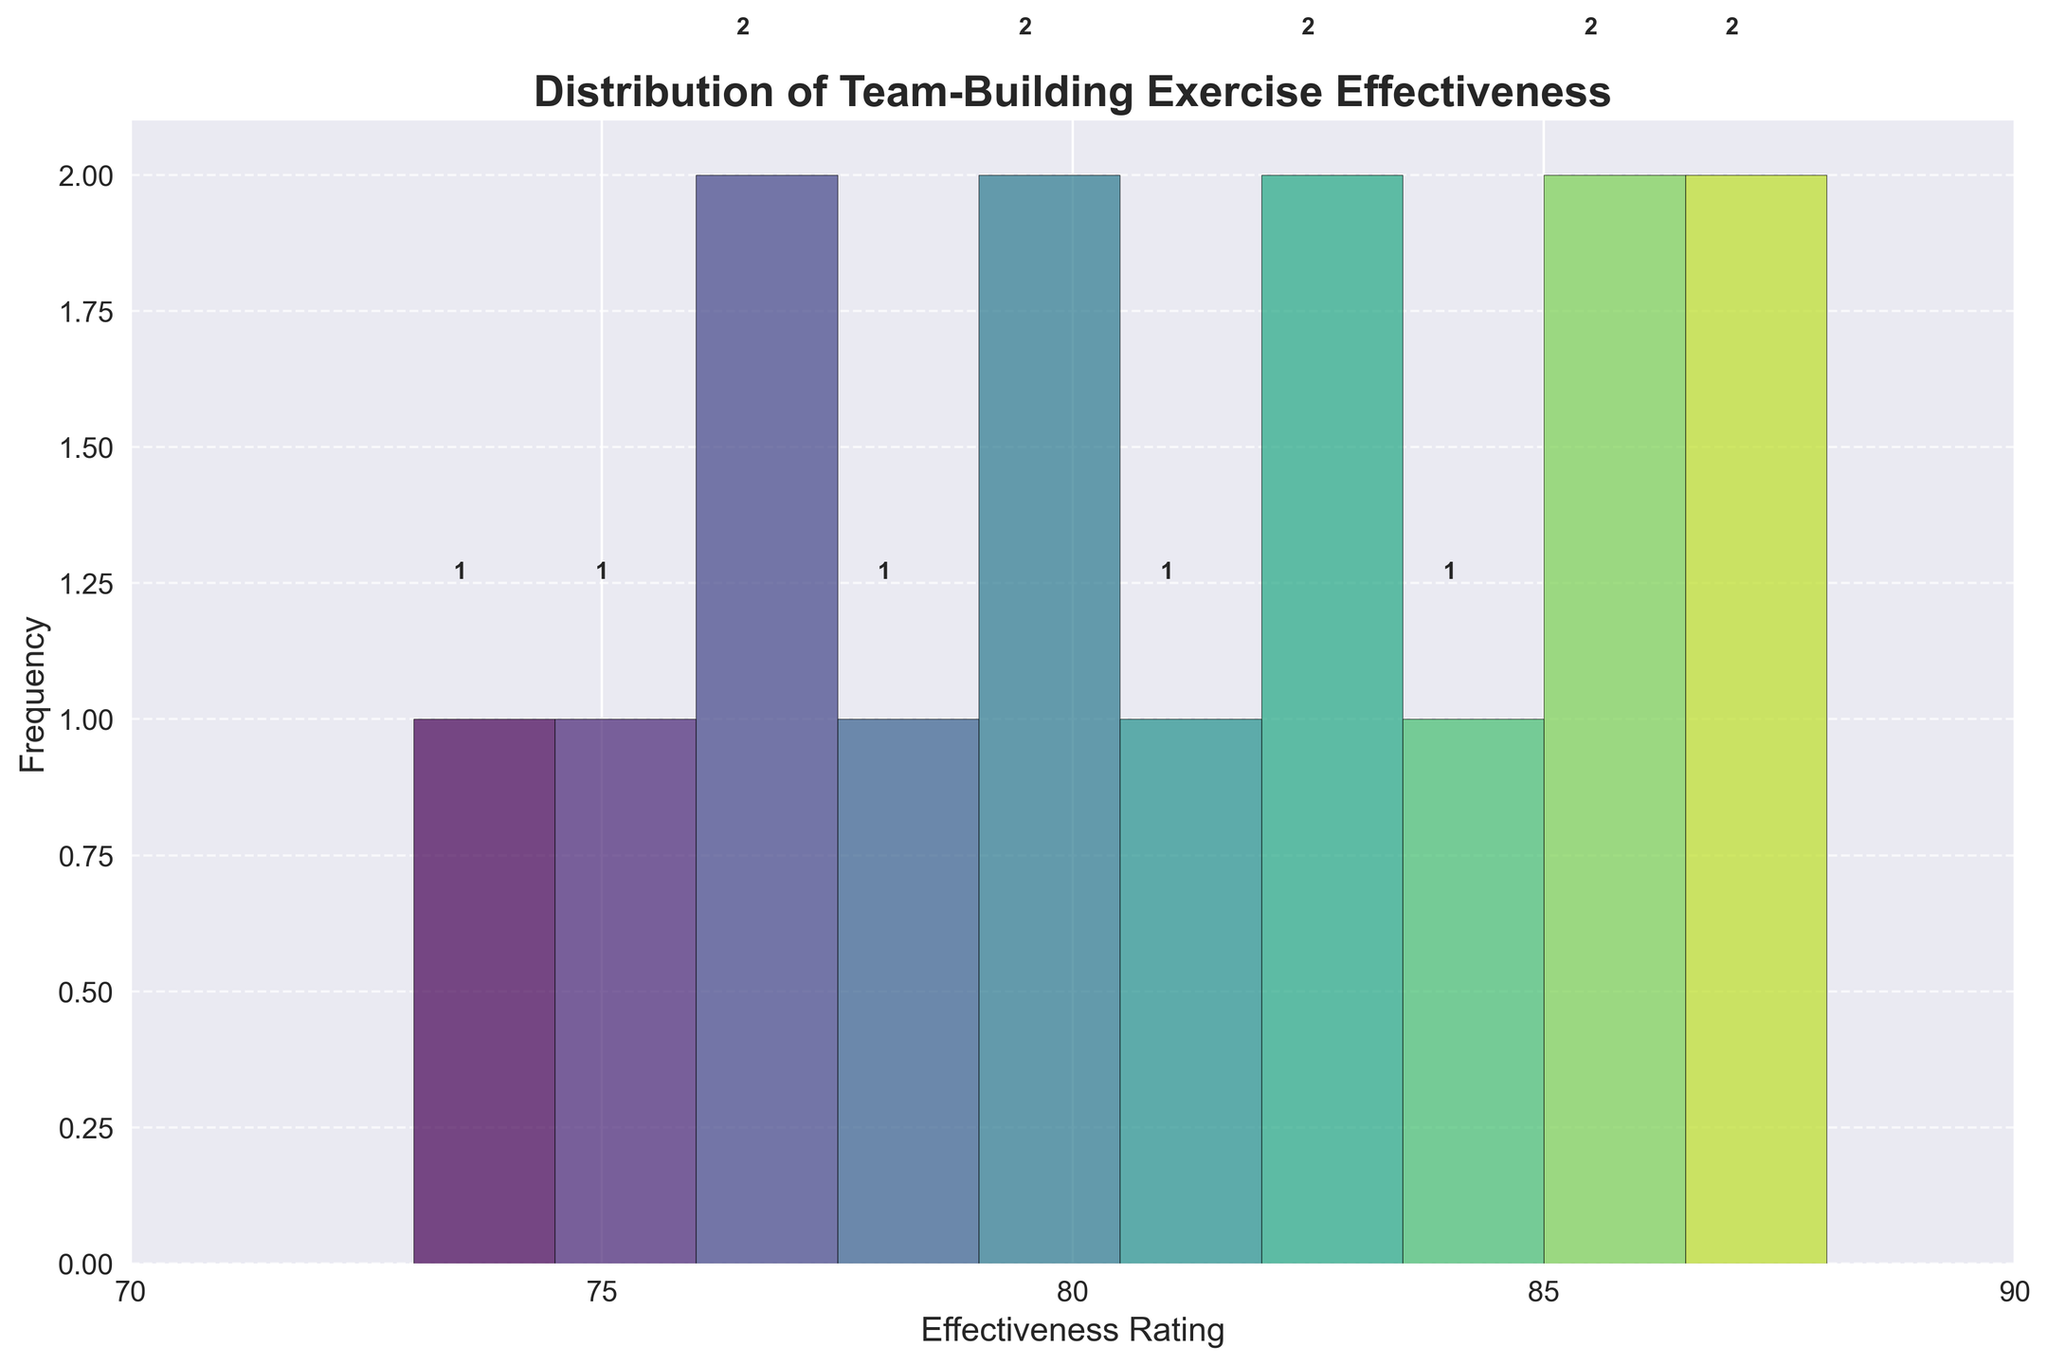What is the title of the plot? The large, bold text centered at the top of the figure indicates the title of the histogram.
Answer: Distribution of Team-Building Exercise Effectiveness How many bins are used in the histogram? By counting the individual vertical bars (bins) along the x-axis, it can be determined that there are 10 bins.
Answer: 10 What range of effectiveness ratings is covered on the x-axis? The scale on the x-axis starts at 70 and ends at 90, evidenced by the tick marks and axis label values.
Answer: 70 to 90 How many exercises fall into the bin with the highest count? Observing the number labels above each bar, the bin with the highest count is marked as having the most occurrences.
Answer: 4 What is the effectiveness rating range of the bin with the largest count? The x-axis values indicate where the bins' boundaries are and the tallest bar falls between 85 and 86.
Answer: 85 to 86 Which participant satisfaction score corresponds to the exercise with the highest effectiveness rating? Referring to the data, the exercise with the highest effectiveness rating of 88 has a participant satisfaction score of 4.6.
Answer: 4.6 Between which two effectiveness rating bins do the counts drop the most sharply? By comparing adjacent bins' counts, the largest drop is between the bins with counts 4 (85–86 bin) to 2 (86–87 bin).
Answer: 85–86 and 86–87 What is the total frequency of exercises with effectiveness ratings of 80 or above? Sum the frequencies of the bins representing ratings from 80 to the highest bin (4+2+2+1+1+2+1).
Answer: 13 How does the color change across the bins, and what pattern does it follow? The color fades from lighter to darker shades of blue, following the viridis colormap pattern gradually.
Answer: It transitions from light to dark blue What is the median value approximately of the effectiveness ratings in the data? Median is the middle value. The ratings are ordered as 73, 75, 76, 77, 78, 79, 80, 81, 82, 83, 84, 85, 86, 87, 88. The median rating is the 8th value in this ordered list.
Answer: 81 